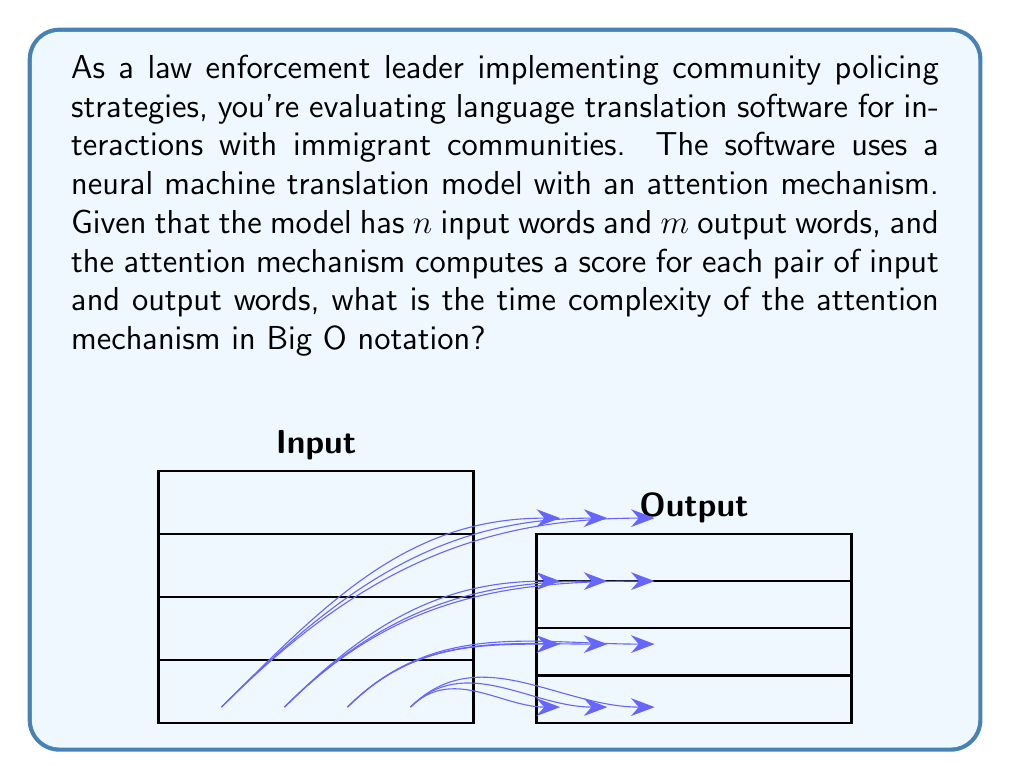Solve this math problem. To determine the time complexity of the attention mechanism, let's break down the process:

1) The attention mechanism computes a score for each pair of input and output words.

2) There are $n$ input words and $m$ output words.

3) For each output word, we need to compute a score with every input word.

4) This means we have $n \times m$ pairs of words to compute scores for.

5) The computation of each score is typically a constant time operation (e.g., dot product of vectors).

6) Therefore, the total number of operations is proportional to $n \times m$.

In Big O notation, we express this as $O(nm)$.

This quadratic time complexity is characteristic of the standard attention mechanism in neural machine translation models. It's important to note that while this allows for high-quality translations by considering all possible word alignments, it can become computationally expensive for very long sentences.

In the context of community policing and immigrant interactions, this implies that the translation software might slow down for longer conversations or documents, which could impact real-time communication in critical situations. However, for most day-to-day interactions, this should not pose a significant problem.
Answer: $O(nm)$ 